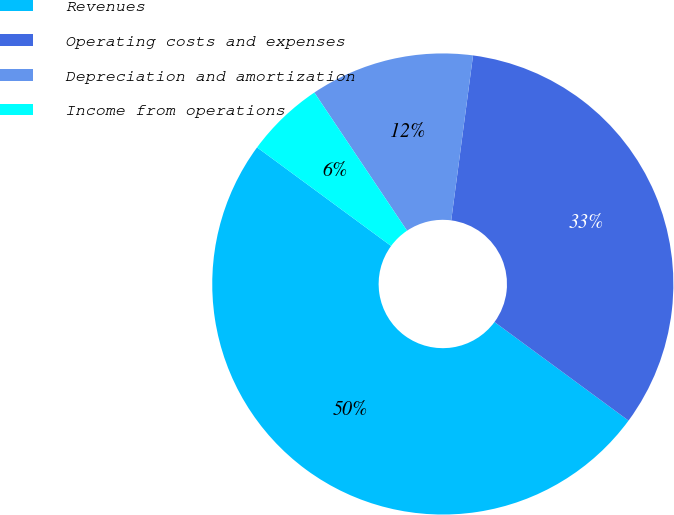<chart> <loc_0><loc_0><loc_500><loc_500><pie_chart><fcel>Revenues<fcel>Operating costs and expenses<fcel>Depreciation and amortization<fcel>Income from operations<nl><fcel>50.0%<fcel>33.0%<fcel>11.5%<fcel>5.5%<nl></chart> 